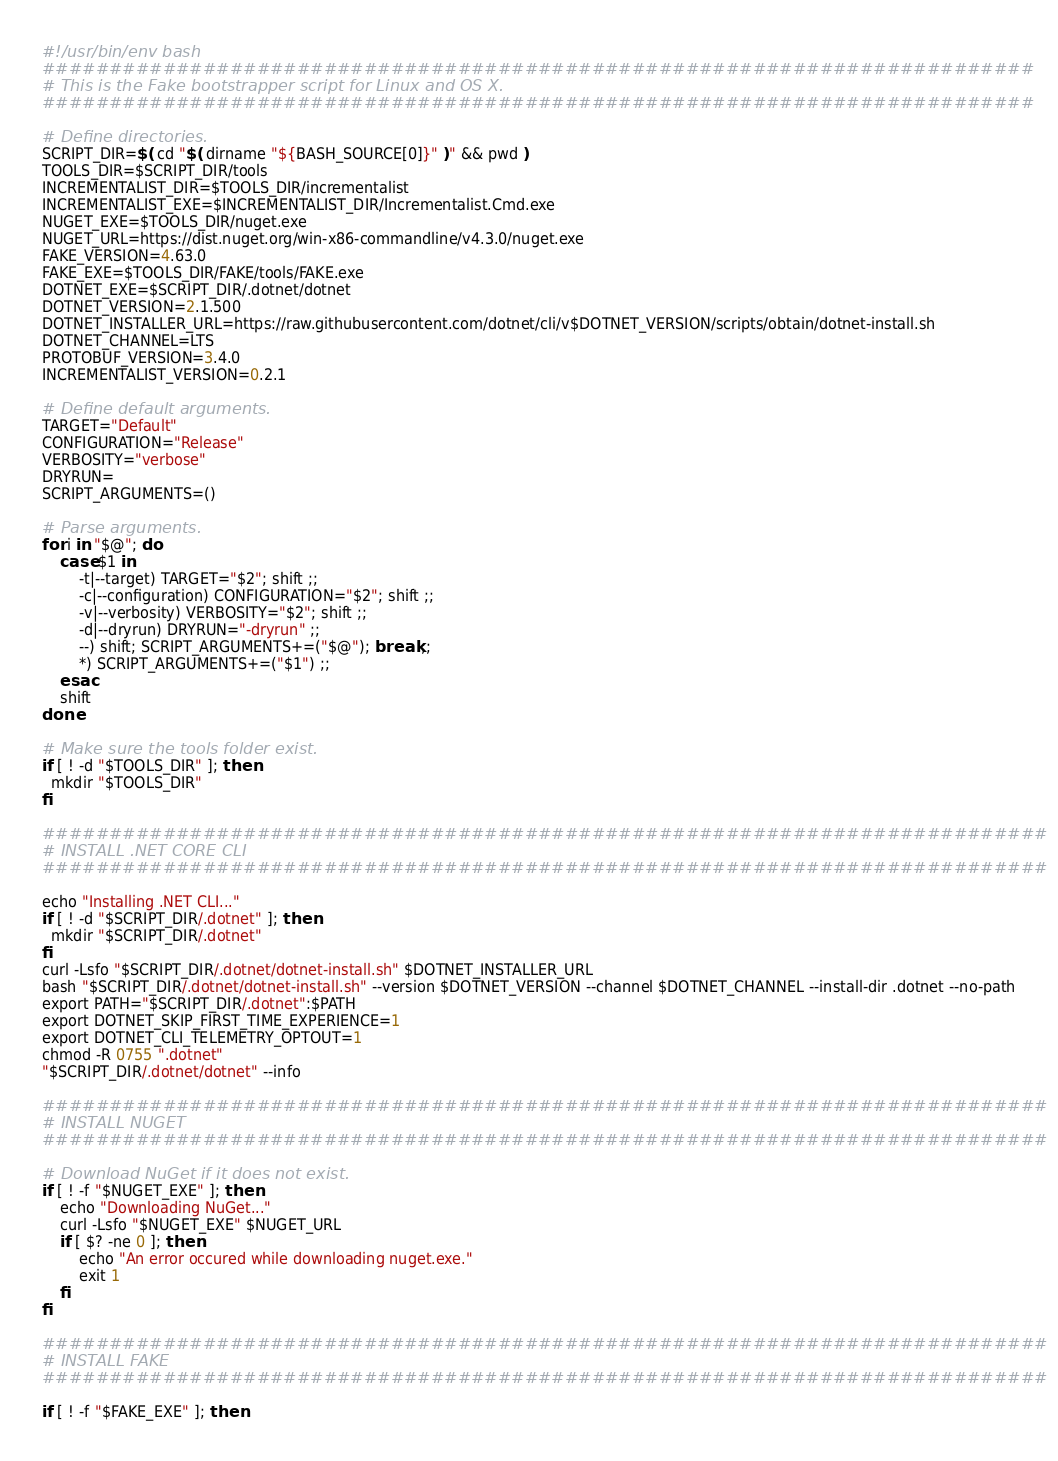<code> <loc_0><loc_0><loc_500><loc_500><_Bash_>#!/usr/bin/env bash
##########################################################################
# This is the Fake bootstrapper script for Linux and OS X.
##########################################################################

# Define directories.
SCRIPT_DIR=$( cd "$( dirname "${BASH_SOURCE[0]}" )" && pwd )
TOOLS_DIR=$SCRIPT_DIR/tools
INCREMENTALIST_DIR=$TOOLS_DIR/incrementalist
INCREMENTALIST_EXE=$INCREMENTALIST_DIR/Incrementalist.Cmd.exe
NUGET_EXE=$TOOLS_DIR/nuget.exe
NUGET_URL=https://dist.nuget.org/win-x86-commandline/v4.3.0/nuget.exe
FAKE_VERSION=4.63.0
FAKE_EXE=$TOOLS_DIR/FAKE/tools/FAKE.exe
DOTNET_EXE=$SCRIPT_DIR/.dotnet/dotnet
DOTNET_VERSION=2.1.500
DOTNET_INSTALLER_URL=https://raw.githubusercontent.com/dotnet/cli/v$DOTNET_VERSION/scripts/obtain/dotnet-install.sh
DOTNET_CHANNEL=LTS
PROTOBUF_VERSION=3.4.0
INCREMENTALIST_VERSION=0.2.1

# Define default arguments.
TARGET="Default"
CONFIGURATION="Release"
VERBOSITY="verbose"
DRYRUN=
SCRIPT_ARGUMENTS=()

# Parse arguments.
for i in "$@"; do
    case $1 in
        -t|--target) TARGET="$2"; shift ;;
        -c|--configuration) CONFIGURATION="$2"; shift ;;
        -v|--verbosity) VERBOSITY="$2"; shift ;;
        -d|--dryrun) DRYRUN="-dryrun" ;;
        --) shift; SCRIPT_ARGUMENTS+=("$@"); break ;;
        *) SCRIPT_ARGUMENTS+=("$1") ;;
    esac
    shift
done

# Make sure the tools folder exist.
if [ ! -d "$TOOLS_DIR" ]; then
  mkdir "$TOOLS_DIR"
fi

###########################################################################
# INSTALL .NET CORE CLI
###########################################################################

echo "Installing .NET CLI..."
if [ ! -d "$SCRIPT_DIR/.dotnet" ]; then
  mkdir "$SCRIPT_DIR/.dotnet"
fi
curl -Lsfo "$SCRIPT_DIR/.dotnet/dotnet-install.sh" $DOTNET_INSTALLER_URL
bash "$SCRIPT_DIR/.dotnet/dotnet-install.sh" --version $DOTNET_VERSION --channel $DOTNET_CHANNEL --install-dir .dotnet --no-path
export PATH="$SCRIPT_DIR/.dotnet":$PATH
export DOTNET_SKIP_FIRST_TIME_EXPERIENCE=1
export DOTNET_CLI_TELEMETRY_OPTOUT=1
chmod -R 0755 ".dotnet"
"$SCRIPT_DIR/.dotnet/dotnet" --info

###########################################################################
# INSTALL NUGET
###########################################################################

# Download NuGet if it does not exist.
if [ ! -f "$NUGET_EXE" ]; then
    echo "Downloading NuGet..."
    curl -Lsfo "$NUGET_EXE" $NUGET_URL
    if [ $? -ne 0 ]; then
        echo "An error occured while downloading nuget.exe."
        exit 1
    fi
fi

###########################################################################
# INSTALL FAKE
###########################################################################

if [ ! -f "$FAKE_EXE" ]; then</code> 